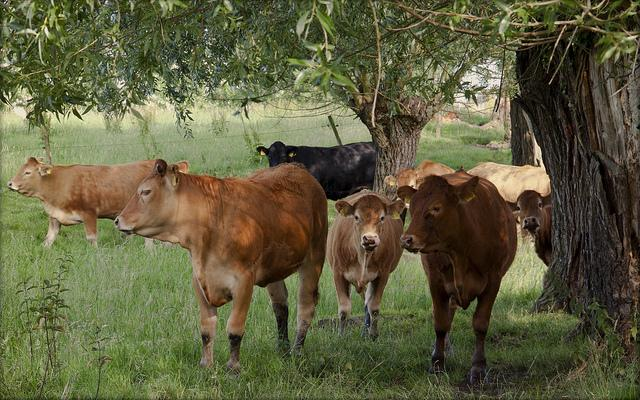What is the young offspring of these animals called?

Choices:
A) kitten
B) calf
C) joey
D) doe calf 